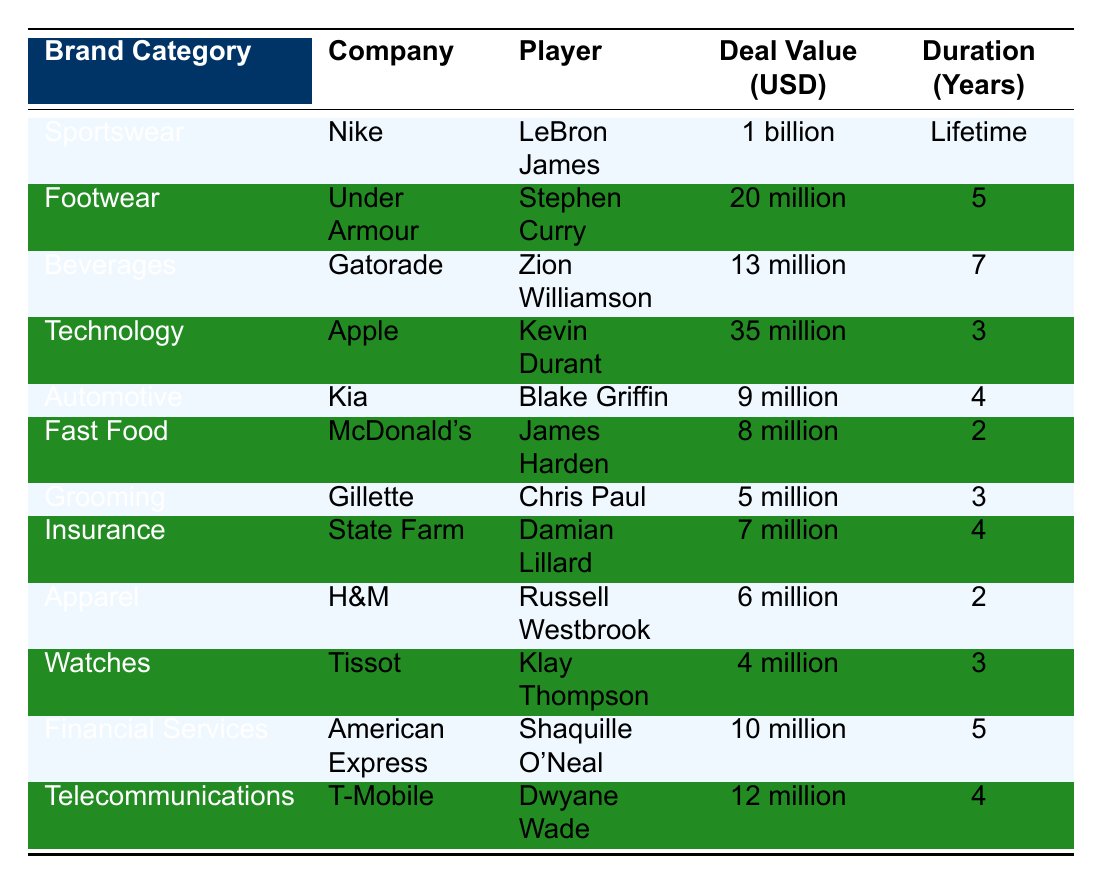What is the highest Deal Value in the table? The highest deal value listed is for LeBron James with Nike, which is 1 billion USD.
Answer: 1 billion Which player has the shortest endorsement duration? James Harden has an endorsement deal with McDonald's for 2 years, making it the shortest duration in the table.
Answer: 2 years How much is the total deal value of the players in the Automotive category? The Automotive category includes Kia's deal with Blake Griffin worth 9 million USD. Thus, the total deal value in this category is 9 million USD.
Answer: 9 million Is the deal value of Gatorade greater than that of Gillette? Gatorade's deal with Zion Williamson is 13 million USD, while Gillette's deal with Chris Paul is 5 million USD. Since 13 million is greater than 5 million, the statement is true.
Answer: Yes What is the average deal value of players in the Beverages and Fast Food categories? Beverages include Gatorade at 13 million, and Fast Food includes McDonald's at 8 million. The sum is 13 + 8 = 21 million. There are 2 players, so the average is 21/2 = 10.5 million.
Answer: 10.5 million Which category has the player with the longest endorsement duration? The Beverages category has Zion Williamson with a 7-year deal, the longest duration compared to the others in the table.
Answer: Beverages How many more years does Stephen Curry's deal last compared to Chris Paul's? Stephen Curry's deal with Under Armour is for 5 years, and Chris Paul's deal with Gillette is for 3 years. The difference is 5 - 3 = 2 years.
Answer: 2 years Are players in the Technology category receiving more than those in the Grooming category? Kevin Durant's deal with Apple is worth 35 million, while Chris Paul's deal with Gillette is worth 5 million. Since 35 million is greater than 5 million, the answer is yes.
Answer: Yes What is the total value of all endorsement deals listed in the table? The total is calculated by adding up all the deal values: 1 billion + 20 million + 13 million + 35 million + 9 million + 8 million + 5 million + 7 million + 6 million + 4 million + 10 million + 12 million. The sum is 1,125 million USD (1 billion = 1,000 million, plus all others).
Answer: 1,125 million In which category is the least valuable endorsement deal located? The Watches category holds the least valuable deal with Klay Thompson, which is 4 million USD.
Answer: Watches 